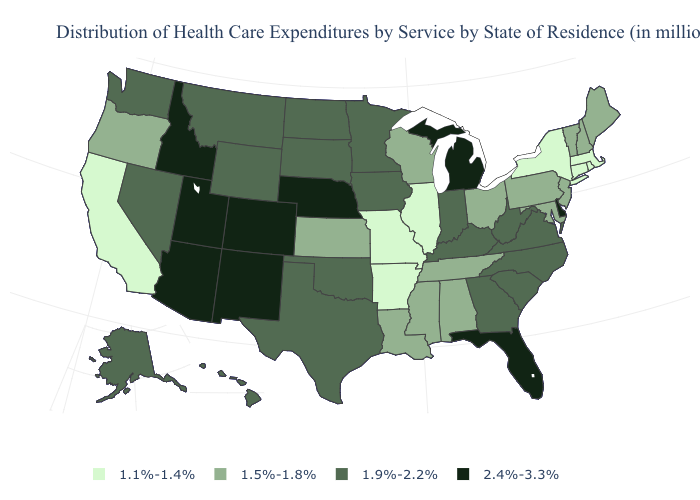Name the states that have a value in the range 1.5%-1.8%?
Concise answer only. Alabama, Kansas, Louisiana, Maine, Maryland, Mississippi, New Hampshire, New Jersey, Ohio, Oregon, Pennsylvania, Tennessee, Vermont, Wisconsin. Name the states that have a value in the range 2.4%-3.3%?
Keep it brief. Arizona, Colorado, Delaware, Florida, Idaho, Michigan, Nebraska, New Mexico, Utah. What is the highest value in the USA?
Answer briefly. 2.4%-3.3%. Does Alabama have the same value as Pennsylvania?
Answer briefly. Yes. What is the lowest value in the USA?
Write a very short answer. 1.1%-1.4%. What is the value of New York?
Concise answer only. 1.1%-1.4%. What is the value of Delaware?
Keep it brief. 2.4%-3.3%. Does the map have missing data?
Keep it brief. No. Name the states that have a value in the range 1.5%-1.8%?
Quick response, please. Alabama, Kansas, Louisiana, Maine, Maryland, Mississippi, New Hampshire, New Jersey, Ohio, Oregon, Pennsylvania, Tennessee, Vermont, Wisconsin. What is the value of Wisconsin?
Write a very short answer. 1.5%-1.8%. Which states have the lowest value in the USA?
Answer briefly. Arkansas, California, Connecticut, Illinois, Massachusetts, Missouri, New York, Rhode Island. What is the value of Kentucky?
Keep it brief. 1.9%-2.2%. Among the states that border Nevada , which have the highest value?
Write a very short answer. Arizona, Idaho, Utah. Does New Hampshire have the highest value in the Northeast?
Answer briefly. Yes. 